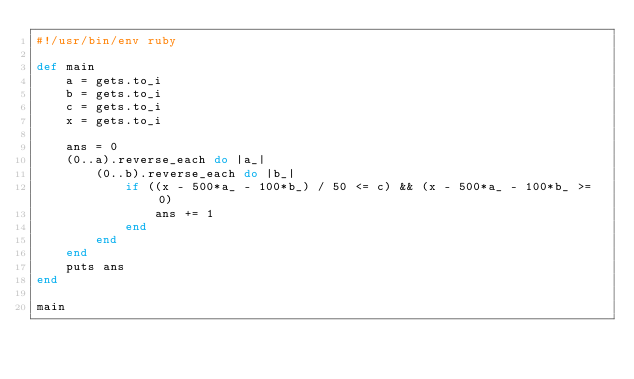<code> <loc_0><loc_0><loc_500><loc_500><_Ruby_>#!/usr/bin/env ruby

def main
    a = gets.to_i
    b = gets.to_i
    c = gets.to_i
    x = gets.to_i

    ans = 0
    (0..a).reverse_each do |a_|
        (0..b).reverse_each do |b_|
            if ((x - 500*a_ - 100*b_) / 50 <= c) && (x - 500*a_ - 100*b_ >= 0)
                ans += 1
            end
        end
    end
    puts ans
end

main</code> 